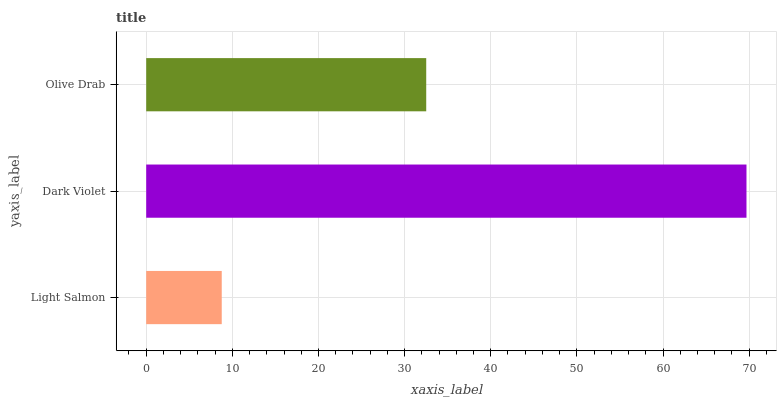Is Light Salmon the minimum?
Answer yes or no. Yes. Is Dark Violet the maximum?
Answer yes or no. Yes. Is Olive Drab the minimum?
Answer yes or no. No. Is Olive Drab the maximum?
Answer yes or no. No. Is Dark Violet greater than Olive Drab?
Answer yes or no. Yes. Is Olive Drab less than Dark Violet?
Answer yes or no. Yes. Is Olive Drab greater than Dark Violet?
Answer yes or no. No. Is Dark Violet less than Olive Drab?
Answer yes or no. No. Is Olive Drab the high median?
Answer yes or no. Yes. Is Olive Drab the low median?
Answer yes or no. Yes. Is Dark Violet the high median?
Answer yes or no. No. Is Light Salmon the low median?
Answer yes or no. No. 